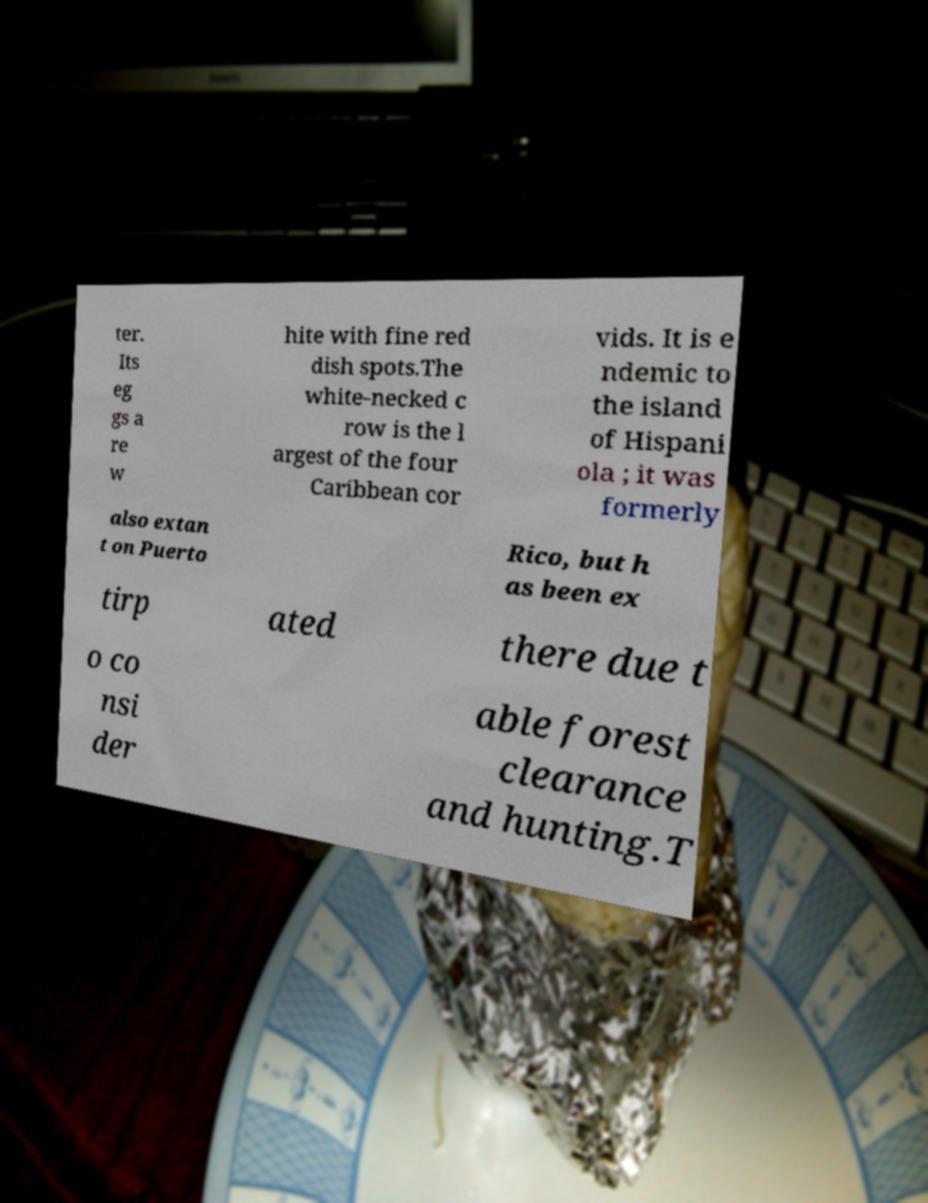Could you extract and type out the text from this image? ter. Its eg gs a re w hite with fine red dish spots.The white-necked c row is the l argest of the four Caribbean cor vids. It is e ndemic to the island of Hispani ola ; it was formerly also extan t on Puerto Rico, but h as been ex tirp ated there due t o co nsi der able forest clearance and hunting.T 